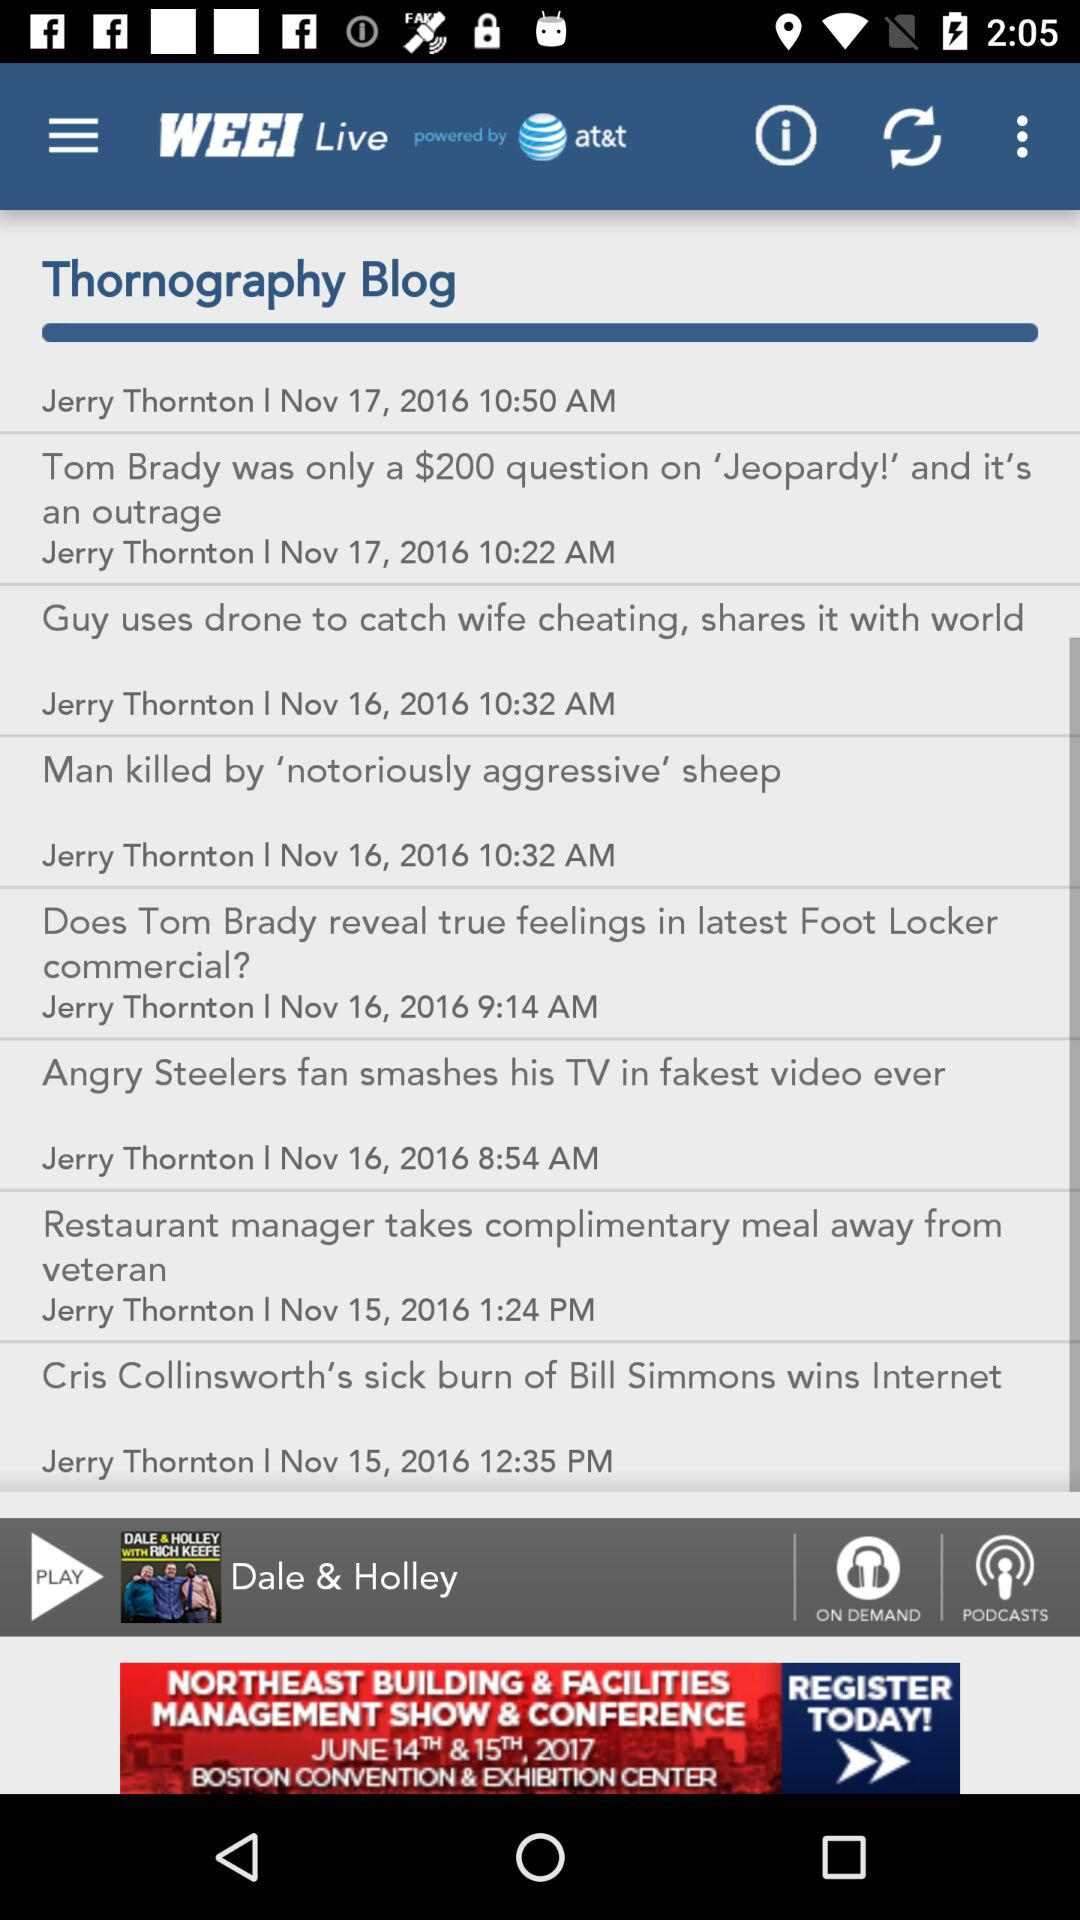When does the blog subscription expire?
When the provided information is insufficient, respond with <no answer>. <no answer> 